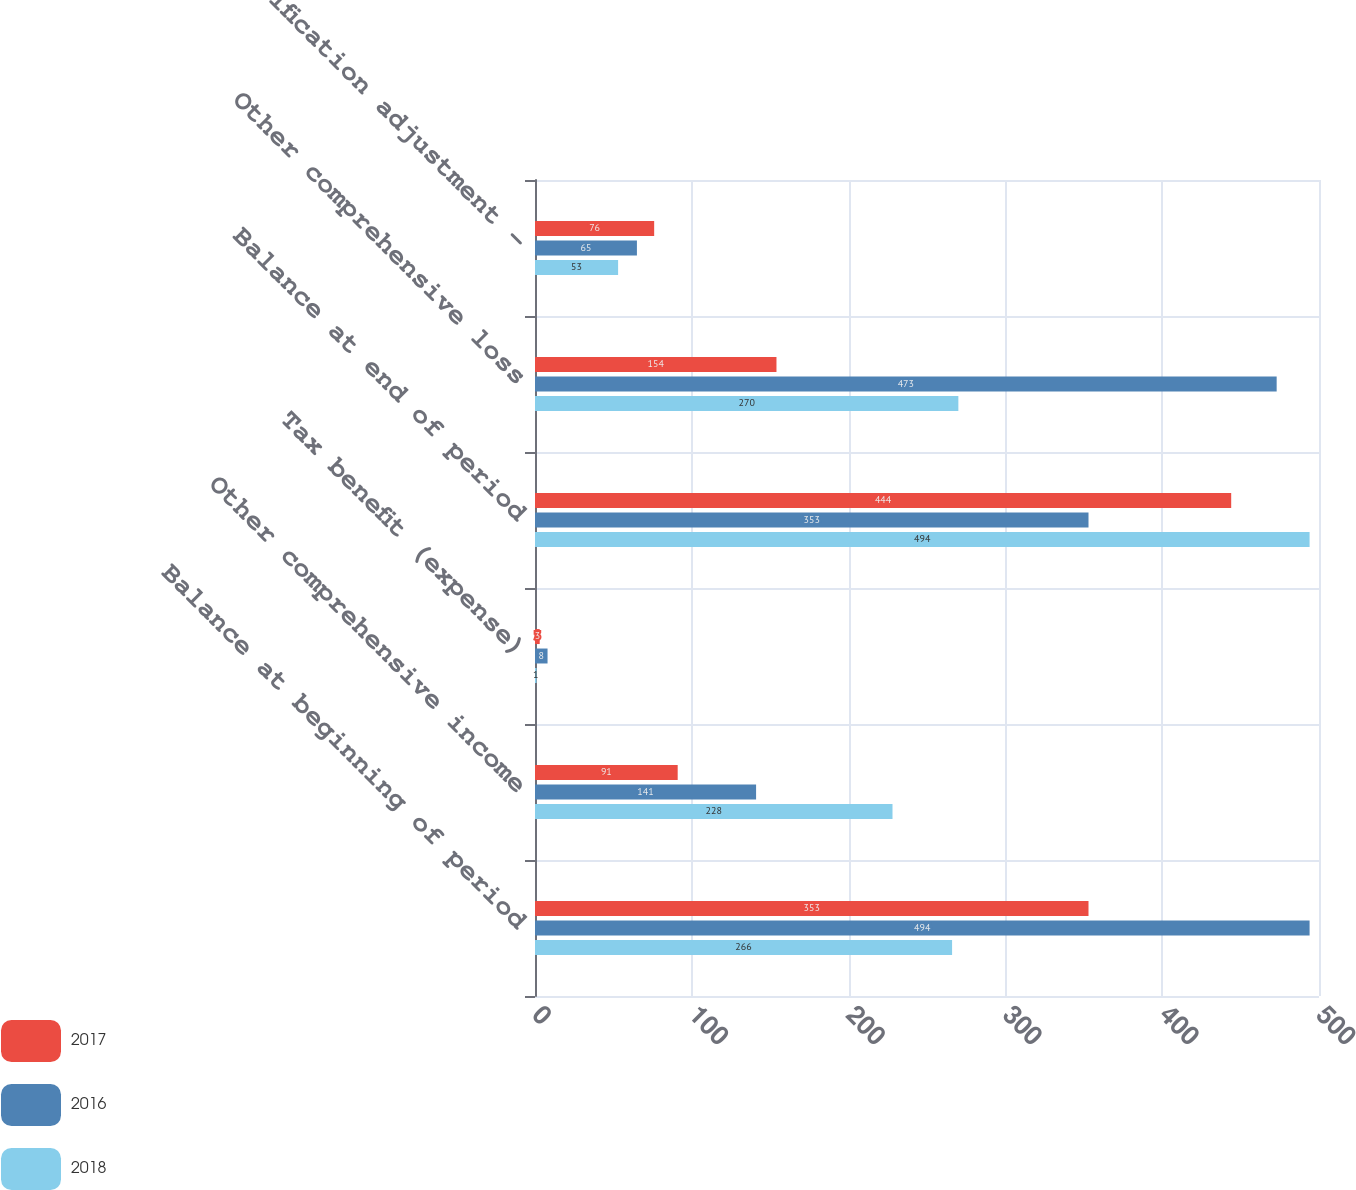<chart> <loc_0><loc_0><loc_500><loc_500><stacked_bar_chart><ecel><fcel>Balance at beginning of period<fcel>Other comprehensive income<fcel>Tax benefit (expense)<fcel>Balance at end of period<fcel>Other comprehensive loss<fcel>Reclassification adjustment -<nl><fcel>2017<fcel>353<fcel>91<fcel>3<fcel>444<fcel>154<fcel>76<nl><fcel>2016<fcel>494<fcel>141<fcel>8<fcel>353<fcel>473<fcel>65<nl><fcel>2018<fcel>266<fcel>228<fcel>1<fcel>494<fcel>270<fcel>53<nl></chart> 